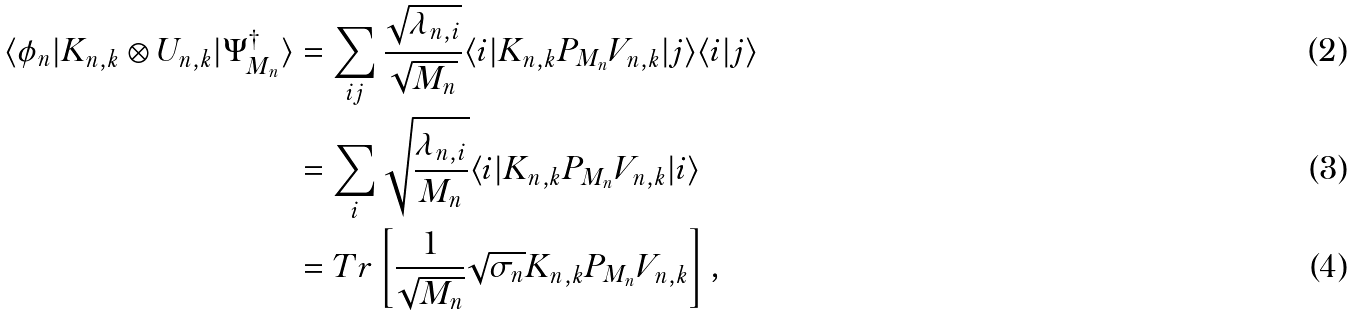Convert formula to latex. <formula><loc_0><loc_0><loc_500><loc_500>\langle \phi _ { n } | K _ { n , k } \otimes U _ { n , k } | \Psi _ { M _ { n } } ^ { \dagger } \rangle & = \sum _ { i j } \frac { { \sqrt { \lambda _ { n , i } } } } { { \sqrt { M _ { n } } } } \langle i | K _ { n , k } P _ { M _ { n } } V _ { n , k } | j \rangle \langle i | j \rangle \\ & = \sum _ { i } \sqrt { \frac { { \lambda _ { n , i } } } { M _ { n } } } \langle i | K _ { n , k } P _ { M _ { n } } V _ { n , k } | i \rangle \\ & = T r \left [ \frac { 1 } { \sqrt { M _ { n } } } { \sqrt { \sigma _ { n } } } K _ { n , k } P _ { M _ { n } } V _ { n , k } \right ] ,</formula> 